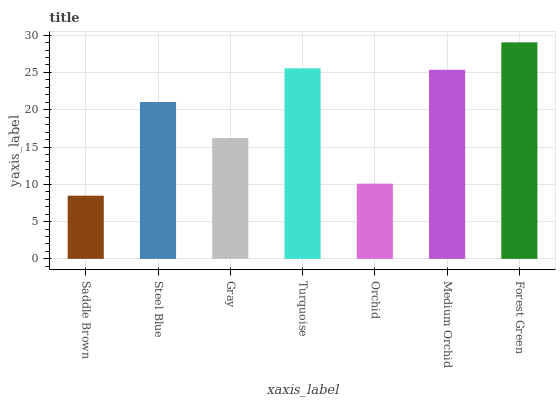Is Saddle Brown the minimum?
Answer yes or no. Yes. Is Forest Green the maximum?
Answer yes or no. Yes. Is Steel Blue the minimum?
Answer yes or no. No. Is Steel Blue the maximum?
Answer yes or no. No. Is Steel Blue greater than Saddle Brown?
Answer yes or no. Yes. Is Saddle Brown less than Steel Blue?
Answer yes or no. Yes. Is Saddle Brown greater than Steel Blue?
Answer yes or no. No. Is Steel Blue less than Saddle Brown?
Answer yes or no. No. Is Steel Blue the high median?
Answer yes or no. Yes. Is Steel Blue the low median?
Answer yes or no. Yes. Is Saddle Brown the high median?
Answer yes or no. No. Is Orchid the low median?
Answer yes or no. No. 